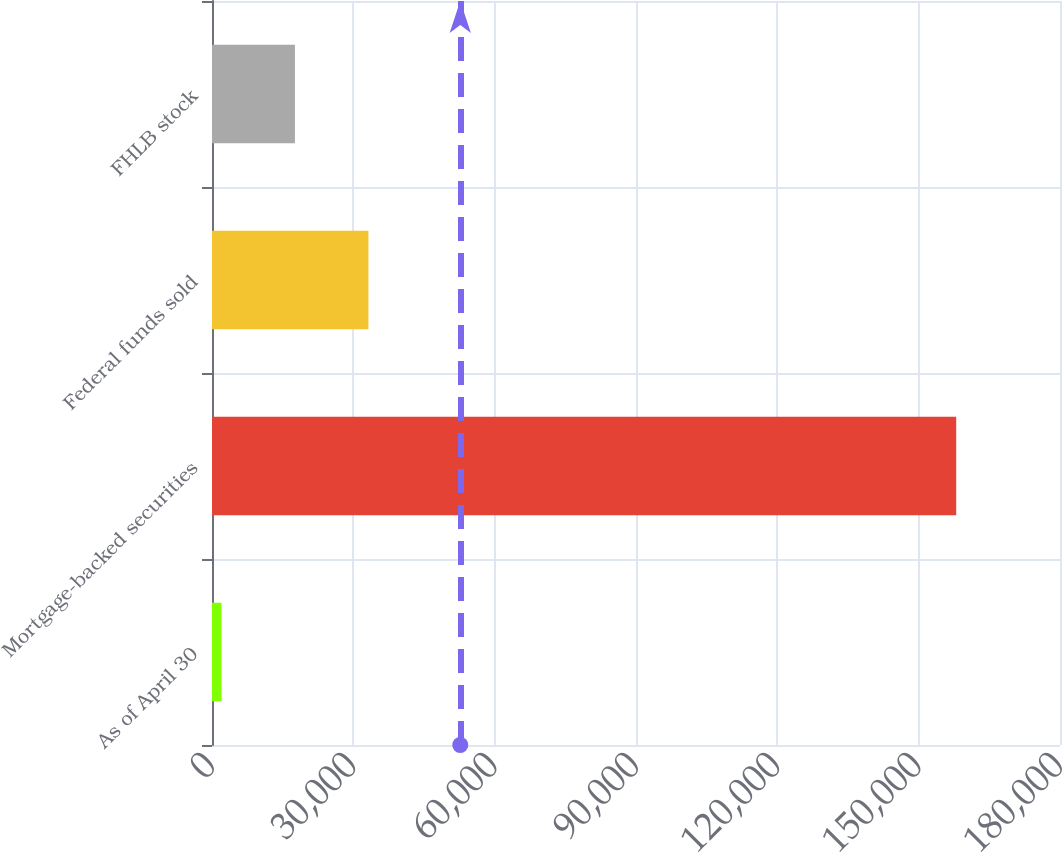<chart> <loc_0><loc_0><loc_500><loc_500><bar_chart><fcel>As of April 30<fcel>Mortgage-backed securities<fcel>Federal funds sold<fcel>FHLB stock<nl><fcel>2011<fcel>157970<fcel>33202.8<fcel>17606.9<nl></chart> 